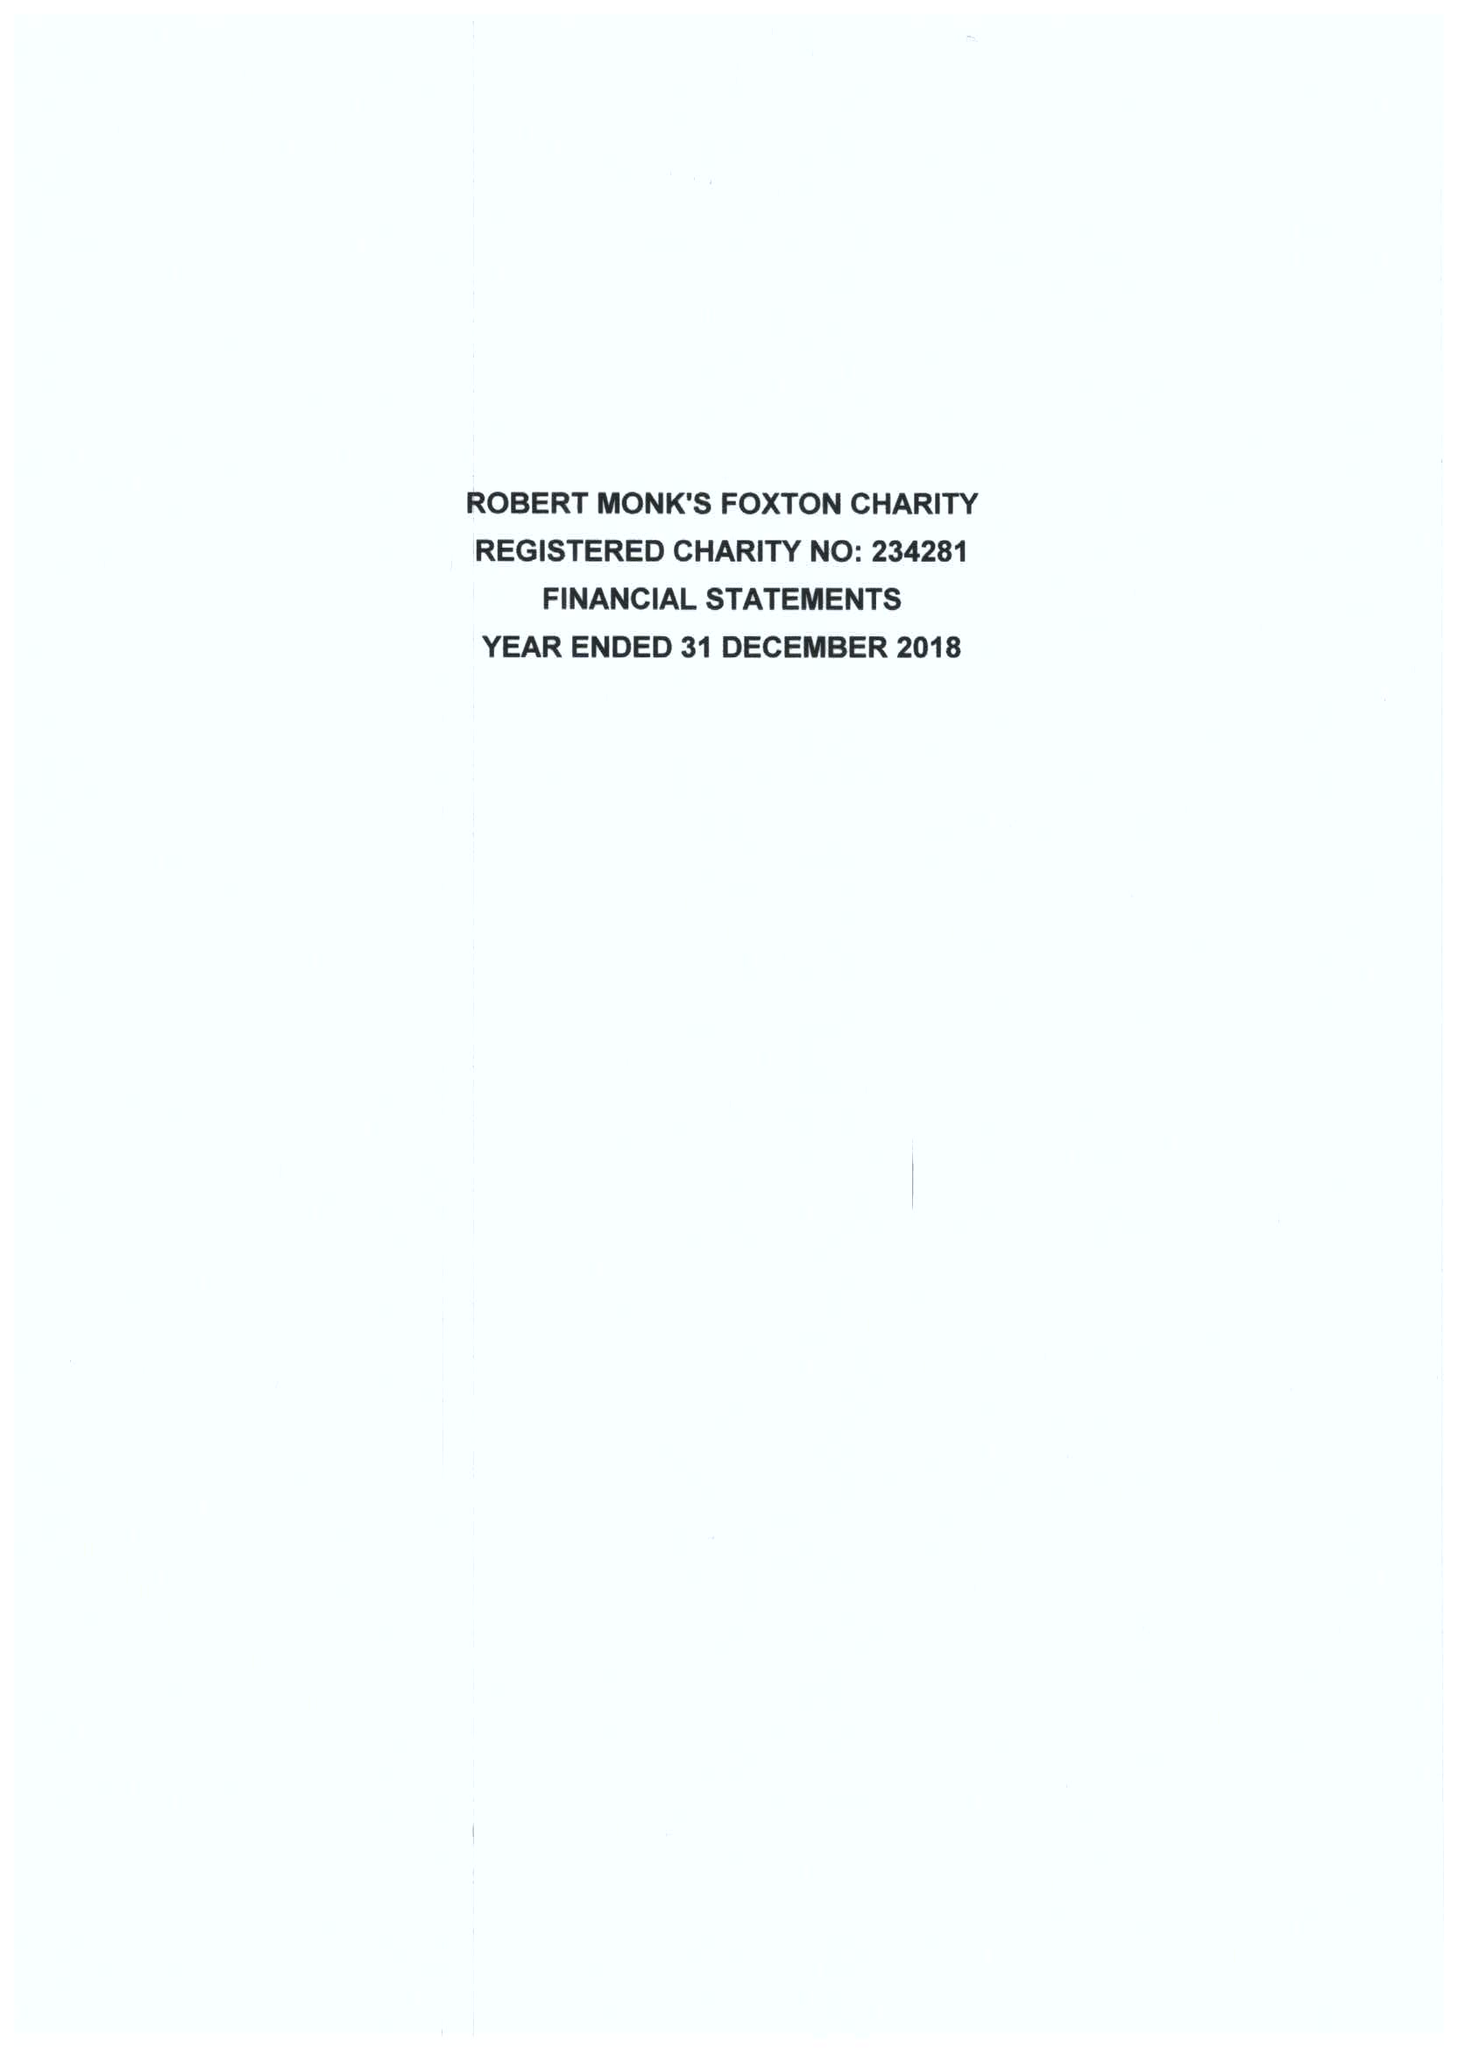What is the value for the charity_number?
Answer the question using a single word or phrase. 234281 